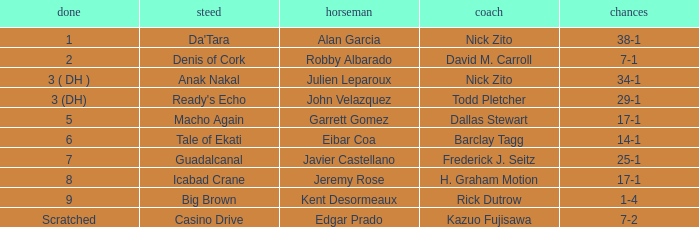Write the full table. {'header': ['done', 'steed', 'horseman', 'coach', 'chances'], 'rows': [['1', "Da'Tara", 'Alan Garcia', 'Nick Zito', '38-1'], ['2', 'Denis of Cork', 'Robby Albarado', 'David M. Carroll', '7-1'], ['3 ( DH )', 'Anak Nakal', 'Julien Leparoux', 'Nick Zito', '34-1'], ['3 (DH)', "Ready's Echo", 'John Velazquez', 'Todd Pletcher', '29-1'], ['5', 'Macho Again', 'Garrett Gomez', 'Dallas Stewart', '17-1'], ['6', 'Tale of Ekati', 'Eibar Coa', 'Barclay Tagg', '14-1'], ['7', 'Guadalcanal', 'Javier Castellano', 'Frederick J. Seitz', '25-1'], ['8', 'Icabad Crane', 'Jeremy Rose', 'H. Graham Motion', '17-1'], ['9', 'Big Brown', 'Kent Desormeaux', 'Rick Dutrow', '1-4'], ['Scratched', 'Casino Drive', 'Edgar Prado', 'Kazuo Fujisawa', '7-2']]} Who is the Jockey that has Nick Zito as Trainer and Odds of 34-1? Julien Leparoux. 